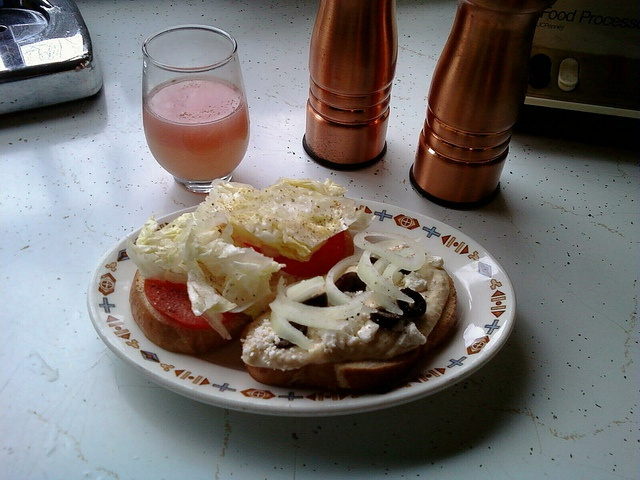Describe the objects in this image and their specific colors. I can see dining table in black, darkgray, gray, lightgray, and maroon tones, sandwich in black, darkgray, maroon, and gray tones, bottle in black, maroon, and brown tones, sandwich in black, maroon, darkgray, olive, and tan tones, and cup in black, darkgray, brown, and gray tones in this image. 